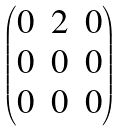<formula> <loc_0><loc_0><loc_500><loc_500>\begin{pmatrix} 0 & 2 & 0 \\ 0 & 0 & 0 \\ 0 & 0 & 0 \end{pmatrix}</formula> 